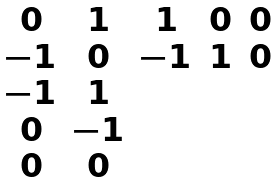<formula> <loc_0><loc_0><loc_500><loc_500>\begin{matrix} 0 & 1 & 1 & 0 & 0 \\ - 1 & 0 & - 1 & 1 & 0 \\ - 1 & 1 \\ 0 & - 1 \\ 0 & 0 \\ \end{matrix}</formula> 